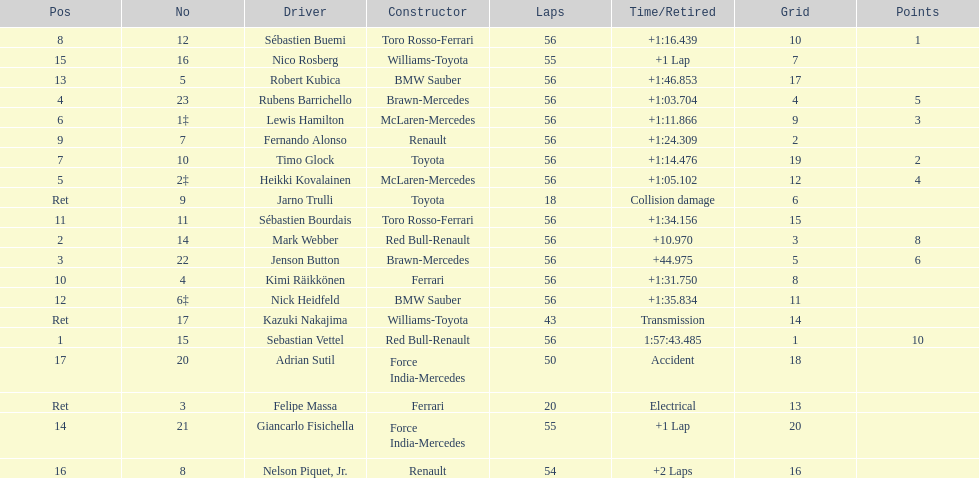What is the total number of drivers on the list? 20. 